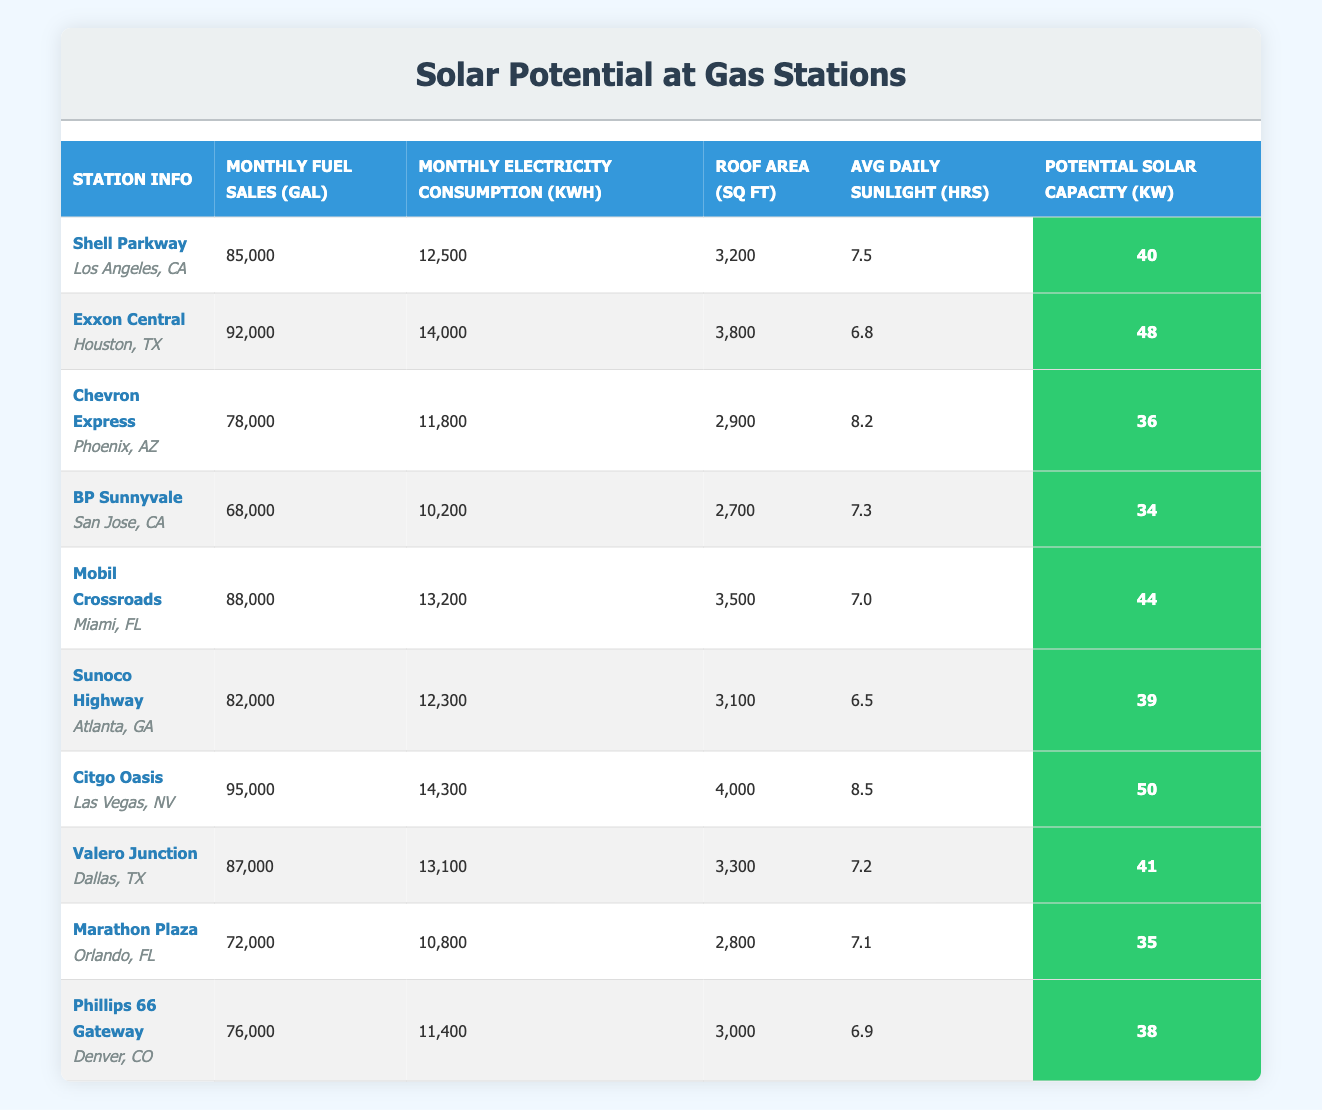What is the monthly fuel sales at Citgo Oasis in Las Vegas, NV? The table shows that Citgo Oasis has monthly fuel sales of 95,000 gallons.
Answer: 95,000 gallons Which gas station has the lowest monthly electricity consumption? By comparing the "Monthly Electricity Consumption (kWh)" column, BP Sunnyvale in San Jose, CA has the lowest consumption at 10,200 kWh.
Answer: BP Sunnyvale What is the average potential solar capacity of the gas stations listed? Summing the potential solar capacities gives (40 + 48 + 36 + 34 + 44 + 39 + 50 + 41 + 35 + 38) =  405. Dividing by 10 (the number of stations) gives an average of 405 / 10 = 40.5.
Answer: 40.5 kW True or False: Exxon Central has higher monthly fuel sales than Mobil Crossroads. Exxon Central has monthly fuel sales of 92,000 gallons, while Mobil Crossroads has 88,000 gallons, so the statement is true.
Answer: True What is the difference between the monthly fuel sales of Shell Parkway and Marathon Plaza? Shell Parkway has 85,000 gallons, and Marathon Plaza has 72,000 gallons. The difference is 85,000 - 72,000 = 13,000 gallons.
Answer: 13,000 gallons Which gas station has the highest average daily sunlight hours? Looking at the "Avg Daily Sunlight (hrs)" column, Citgo Oasis stands out with 8.5 hours, which is the highest among all listed stations.
Answer: Citgo Oasis How many gas stations have monthly fuel sales greater than 80,000 gallons? By reviewing the "Monthly Fuel Sales (gal)" column, four gas stations (Citgo Oasis, Exxon Central, Mobil Crossroads, and Valero Junction) have sales above 80,000 gallons.
Answer: 4 gas stations What is the total monthly electricity consumption of all the gas stations? The total monthly electricity consumption can be calculated by summing all values in the "Monthly Electricity Consumption (kWh)" column: (12,500 + 14,000 + 11,800 + 10,200 + 13,200 + 12,300 + 14,300 + 13,100 + 10,800 + 11,400) =  133,900 kWh.
Answer: 133,900 kWh Which gas station has more roof area: Mobil Crossroads or BP Sunnyvale? Mobil Crossroads has 3,500 sq ft of roof area, while BP Sunnyvale has 2,700 sq ft, indicating Mobil Crossroads has more roof space.
Answer: Mobil Crossroads 